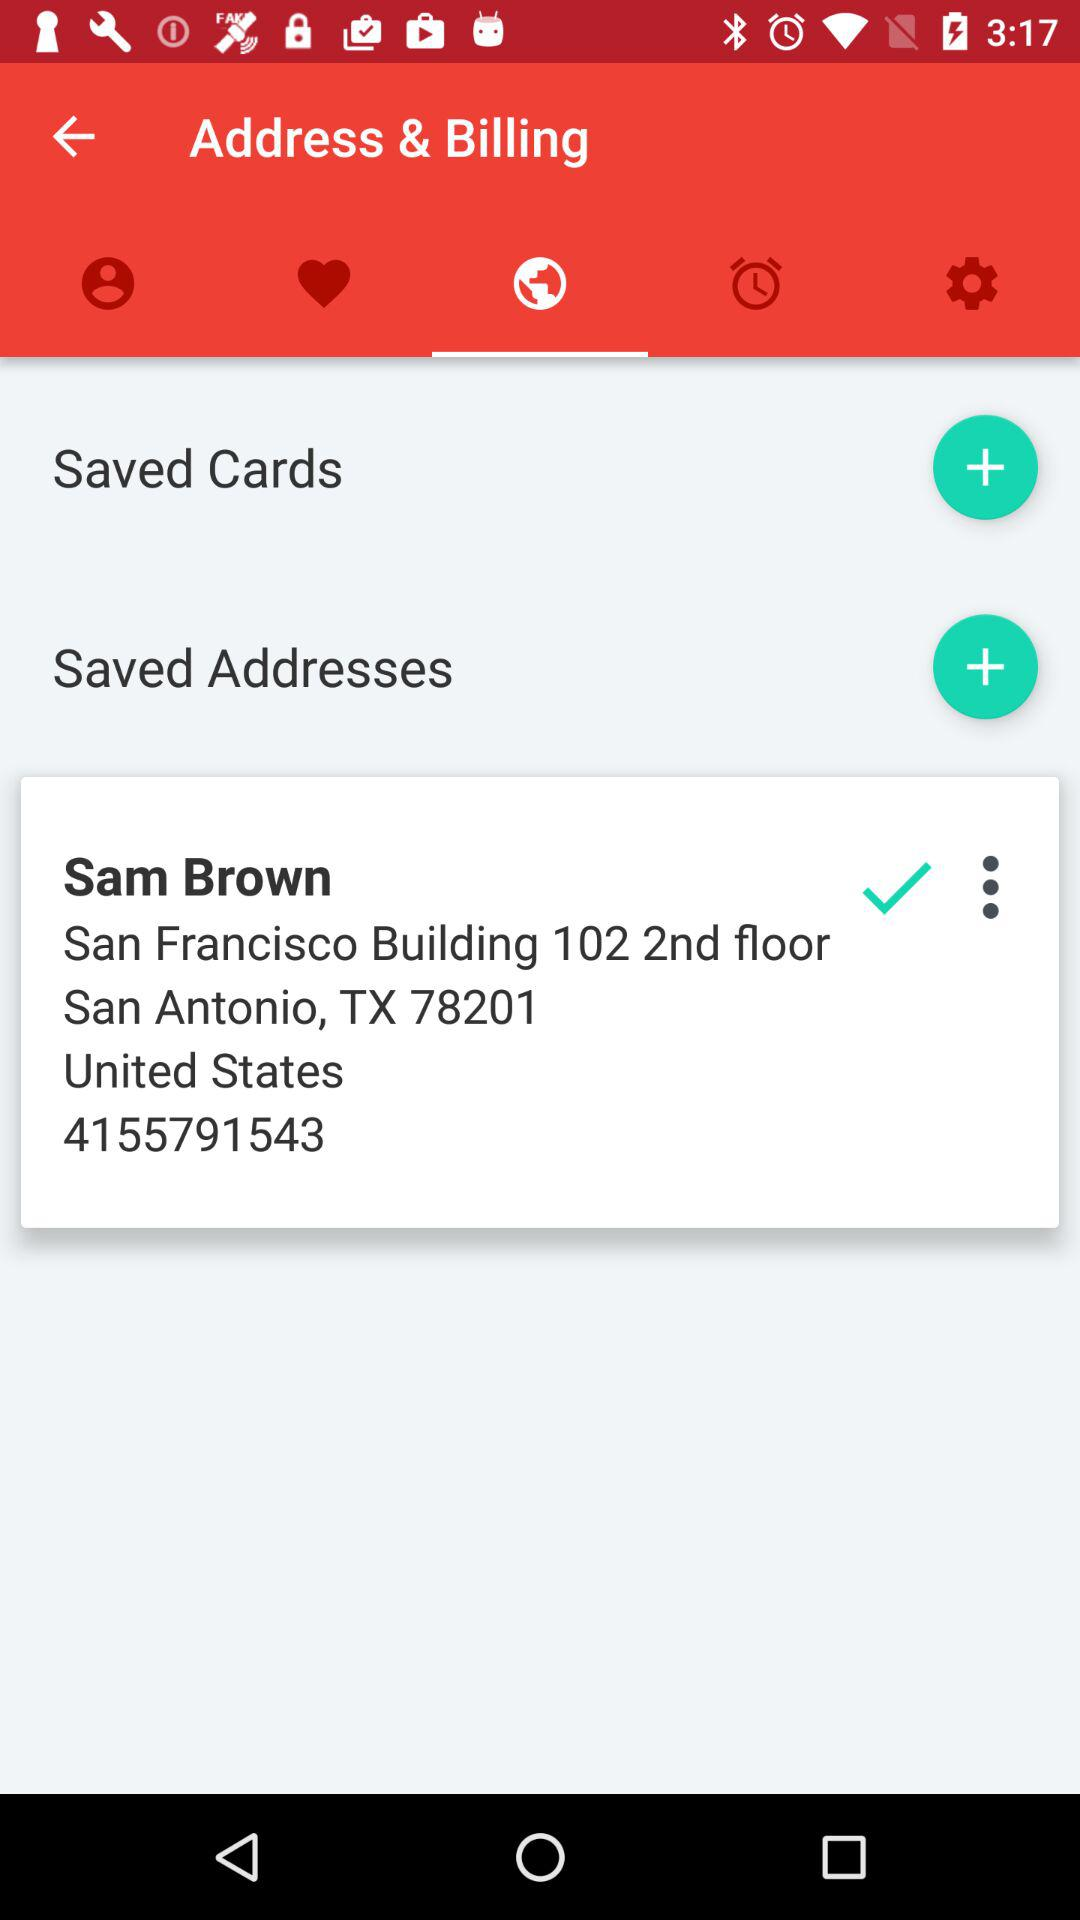What country is Sam from? Sam is from the United States. 